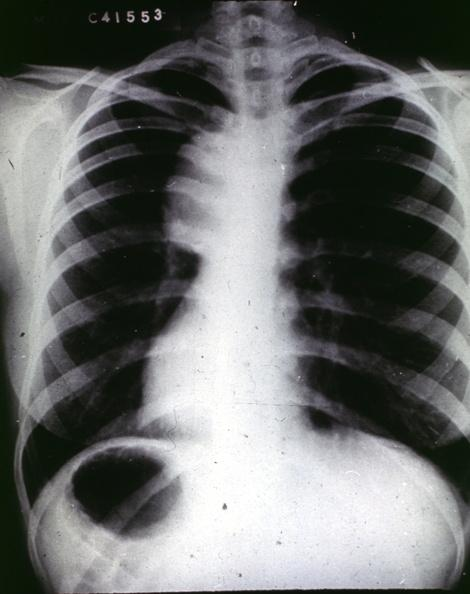s aorta present?
Answer the question using a single word or phrase. Yes 